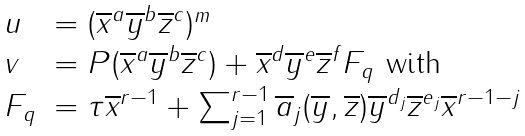<formula> <loc_0><loc_0><loc_500><loc_500>\begin{array} { l l } u & = ( \overline { x } ^ { a } \overline { y } ^ { b } \overline { z } ^ { c } ) ^ { m } \\ v & = P ( \overline { x } ^ { a } \overline { y } ^ { b } \overline { z } ^ { c } ) + \overline { x } ^ { d } \overline { y } ^ { e } \overline { z } ^ { f } F _ { q } \text { with } \\ F _ { q } & = \tau \overline { x } ^ { r - 1 } + \sum _ { j = 1 } ^ { r - 1 } \overline { a } _ { j } ( \overline { y } , \overline { z } ) \overline { y } ^ { d _ { j } } \overline { z } ^ { e _ { j } } \overline { x } ^ { r - 1 - j } \end{array}</formula> 